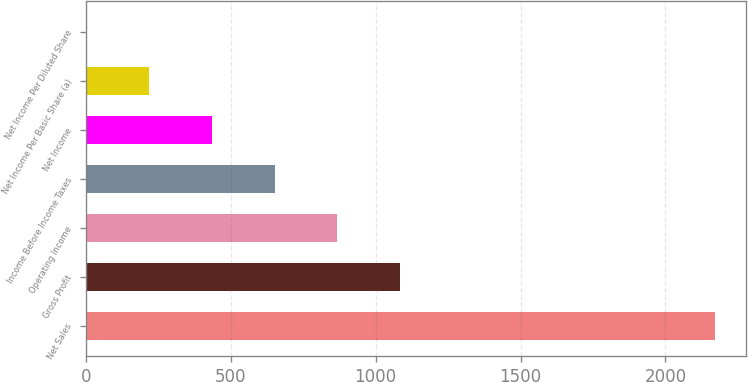Convert chart. <chart><loc_0><loc_0><loc_500><loc_500><bar_chart><fcel>Net Sales<fcel>Gross Profit<fcel>Operating Income<fcel>Income Before Income Taxes<fcel>Net Income<fcel>Net Income Per Basic Share (a)<fcel>Net Income Per Diluted Share<nl><fcel>2171<fcel>1085.66<fcel>868.59<fcel>651.52<fcel>434.45<fcel>217.38<fcel>0.31<nl></chart> 